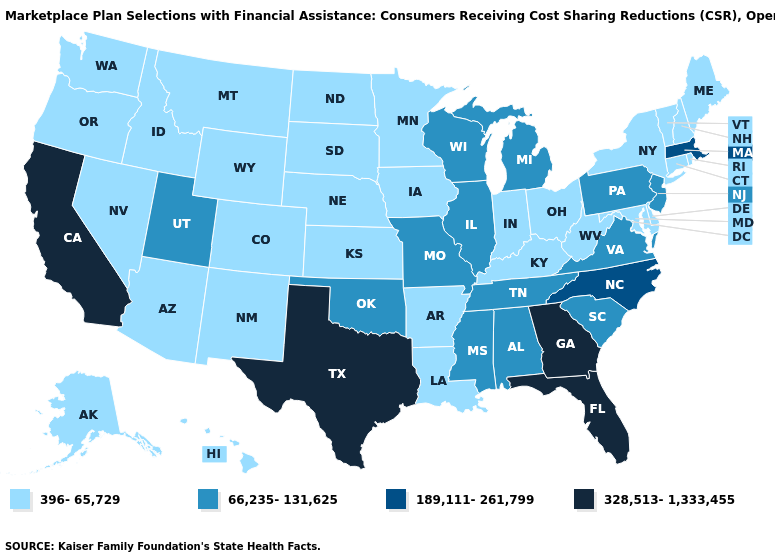What is the lowest value in the West?
Write a very short answer. 396-65,729. Name the states that have a value in the range 396-65,729?
Keep it brief. Alaska, Arizona, Arkansas, Colorado, Connecticut, Delaware, Hawaii, Idaho, Indiana, Iowa, Kansas, Kentucky, Louisiana, Maine, Maryland, Minnesota, Montana, Nebraska, Nevada, New Hampshire, New Mexico, New York, North Dakota, Ohio, Oregon, Rhode Island, South Dakota, Vermont, Washington, West Virginia, Wyoming. Among the states that border Delaware , does Pennsylvania have the highest value?
Quick response, please. Yes. Name the states that have a value in the range 189,111-261,799?
Be succinct. Massachusetts, North Carolina. What is the value of Michigan?
Quick response, please. 66,235-131,625. Does Nevada have the same value as Arizona?
Concise answer only. Yes. What is the highest value in the USA?
Answer briefly. 328,513-1,333,455. Does Kansas have the highest value in the MidWest?
Concise answer only. No. What is the value of Montana?
Short answer required. 396-65,729. Among the states that border New Hampshire , does Massachusetts have the lowest value?
Answer briefly. No. Does the first symbol in the legend represent the smallest category?
Quick response, please. Yes. Among the states that border Kansas , does Missouri have the lowest value?
Write a very short answer. No. Which states have the highest value in the USA?
Quick response, please. California, Florida, Georgia, Texas. What is the value of Washington?
Keep it brief. 396-65,729. 